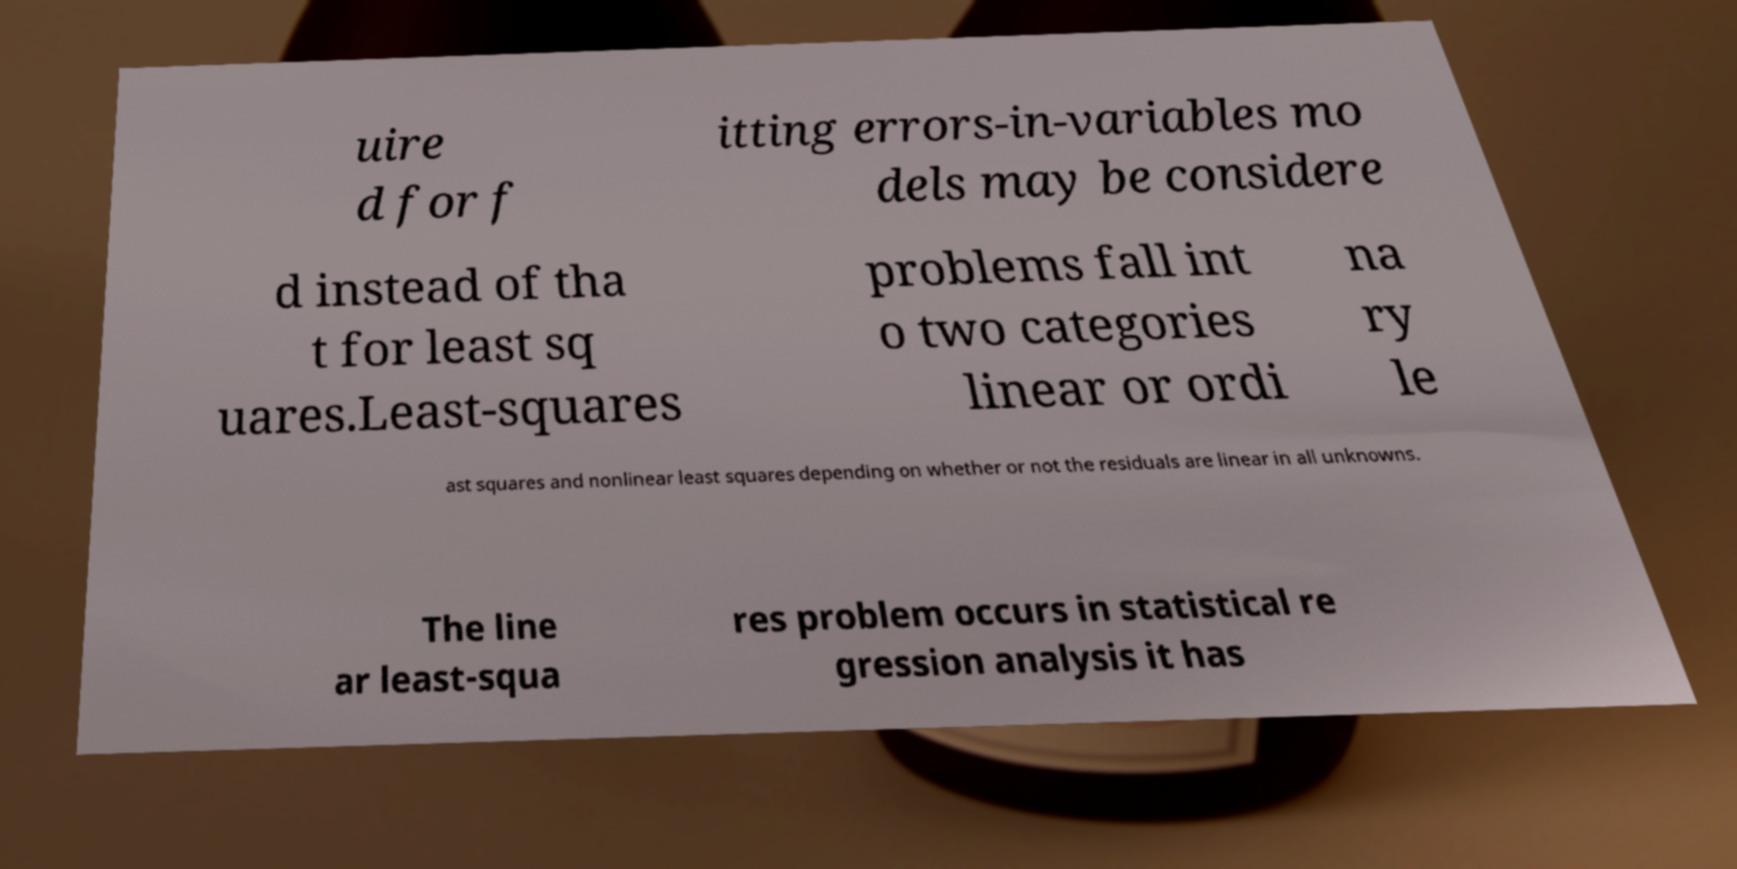For documentation purposes, I need the text within this image transcribed. Could you provide that? uire d for f itting errors-in-variables mo dels may be considere d instead of tha t for least sq uares.Least-squares problems fall int o two categories linear or ordi na ry le ast squares and nonlinear least squares depending on whether or not the residuals are linear in all unknowns. The line ar least-squa res problem occurs in statistical re gression analysis it has 